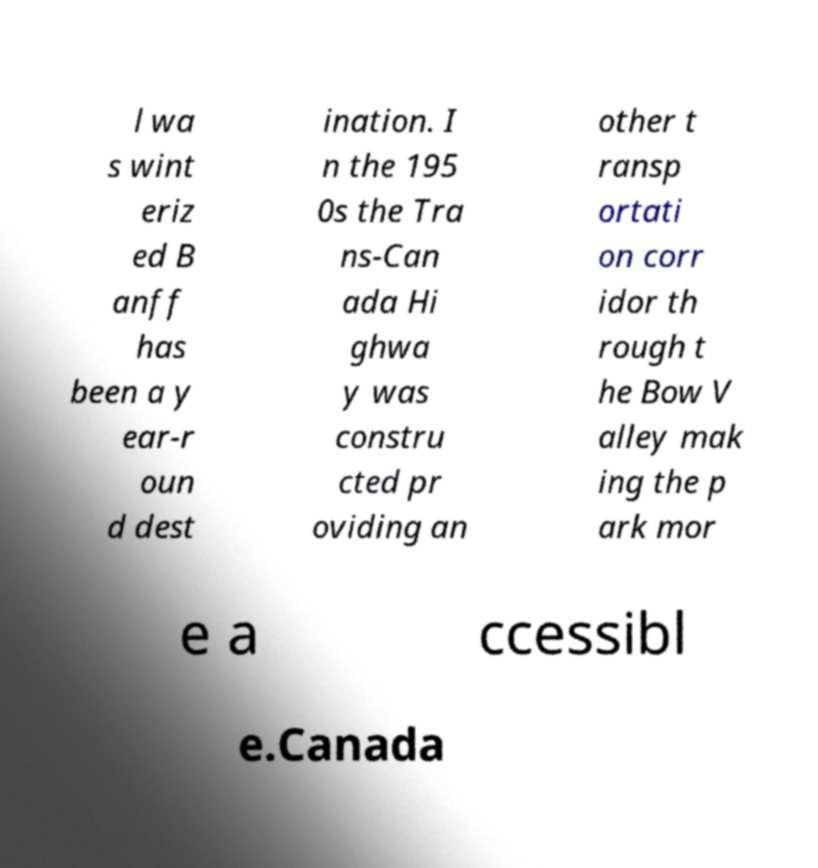There's text embedded in this image that I need extracted. Can you transcribe it verbatim? l wa s wint eriz ed B anff has been a y ear-r oun d dest ination. I n the 195 0s the Tra ns-Can ada Hi ghwa y was constru cted pr oviding an other t ransp ortati on corr idor th rough t he Bow V alley mak ing the p ark mor e a ccessibl e.Canada 